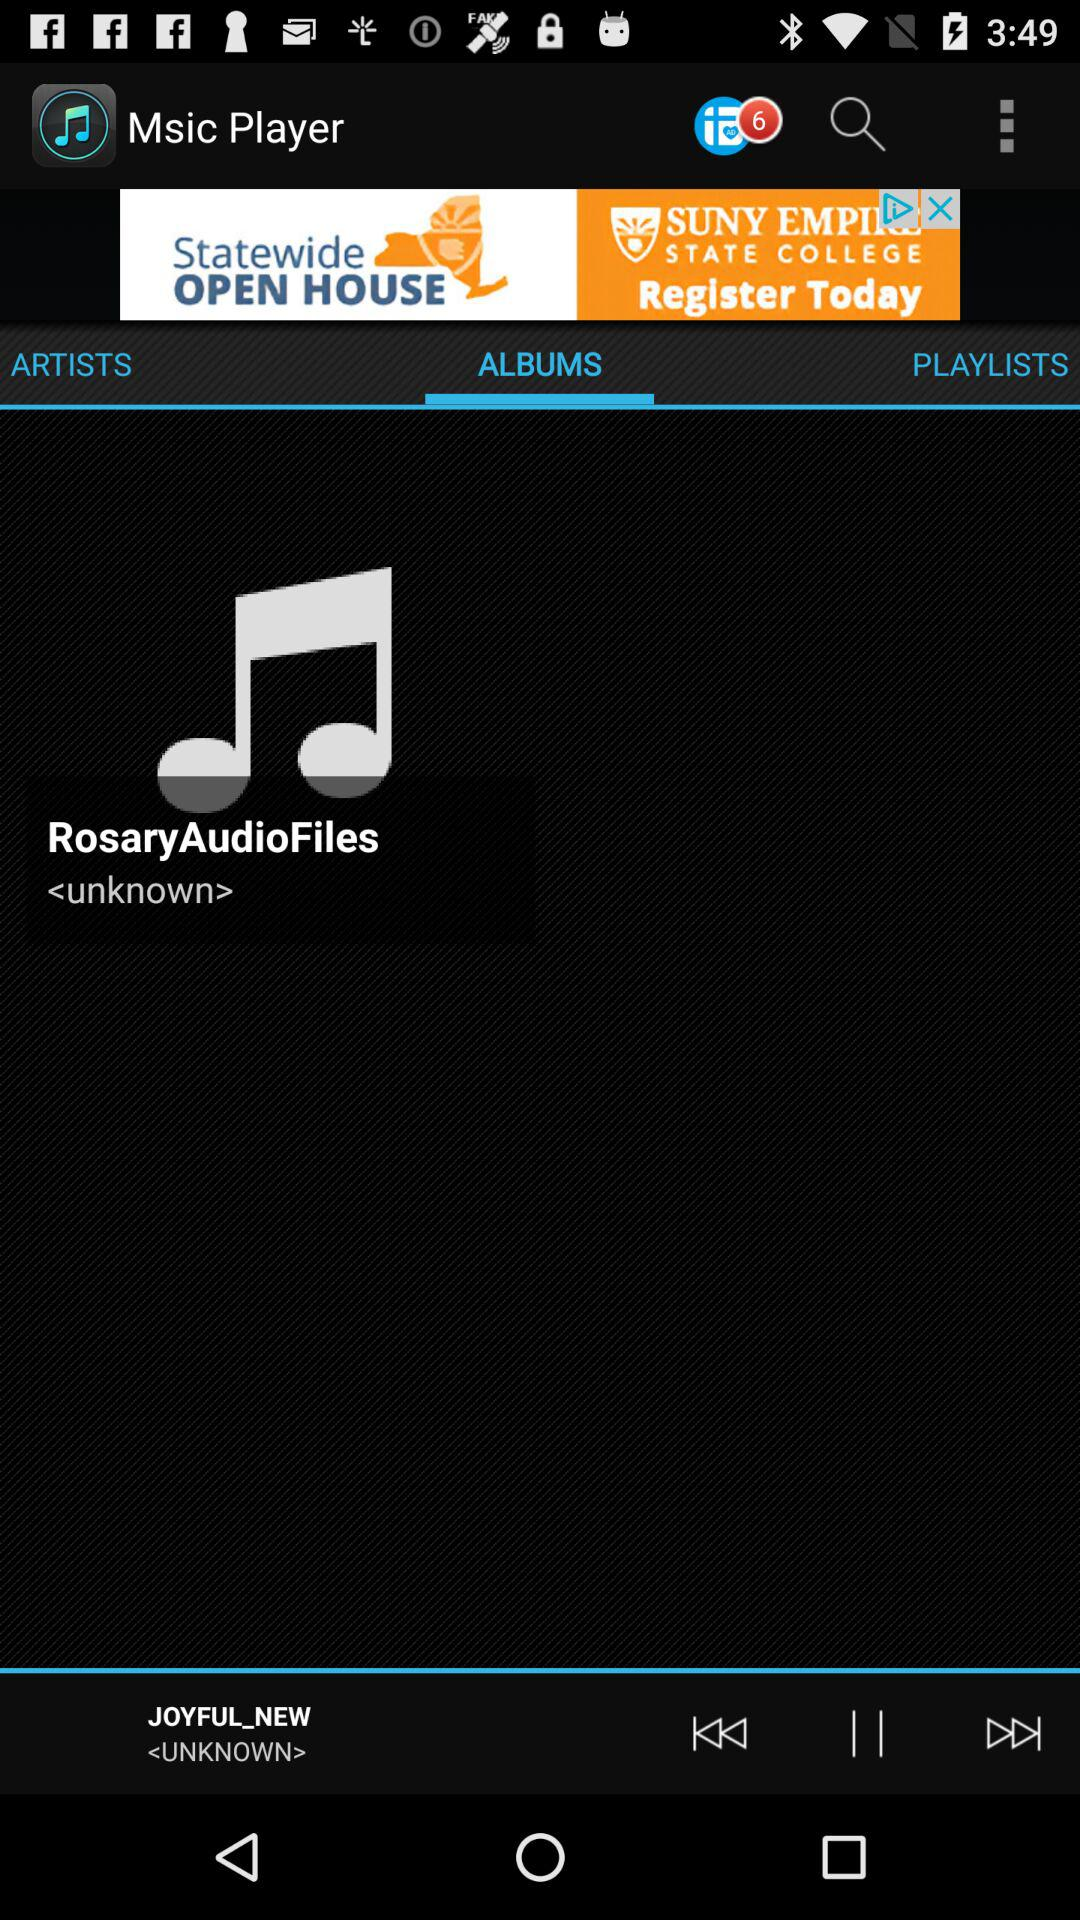What audio is currently playing? The currently playing audio is "JOYFUL_NEW". 